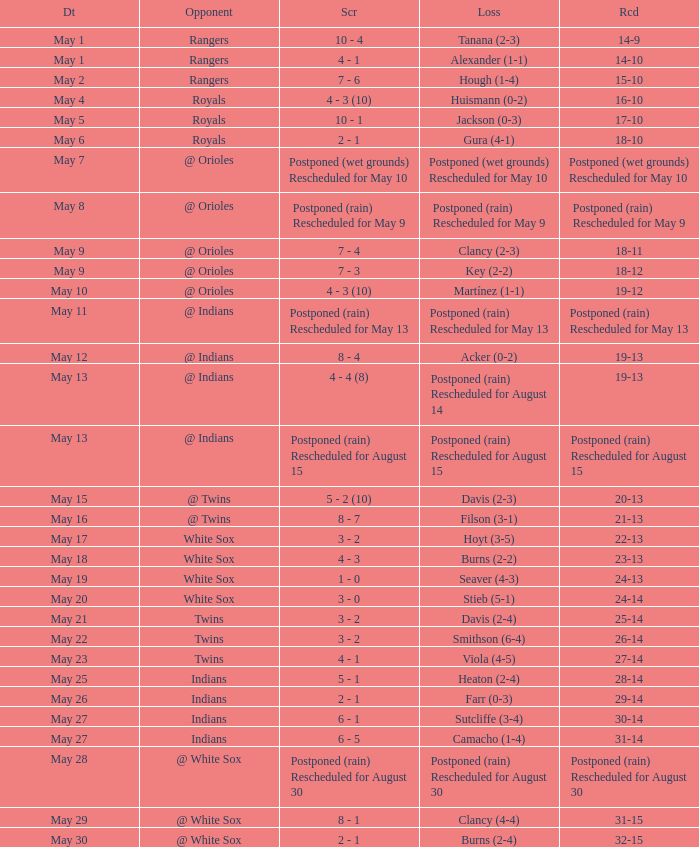What was the record at the game against the Indians with a loss of Camacho (1-4)? 31-14. 